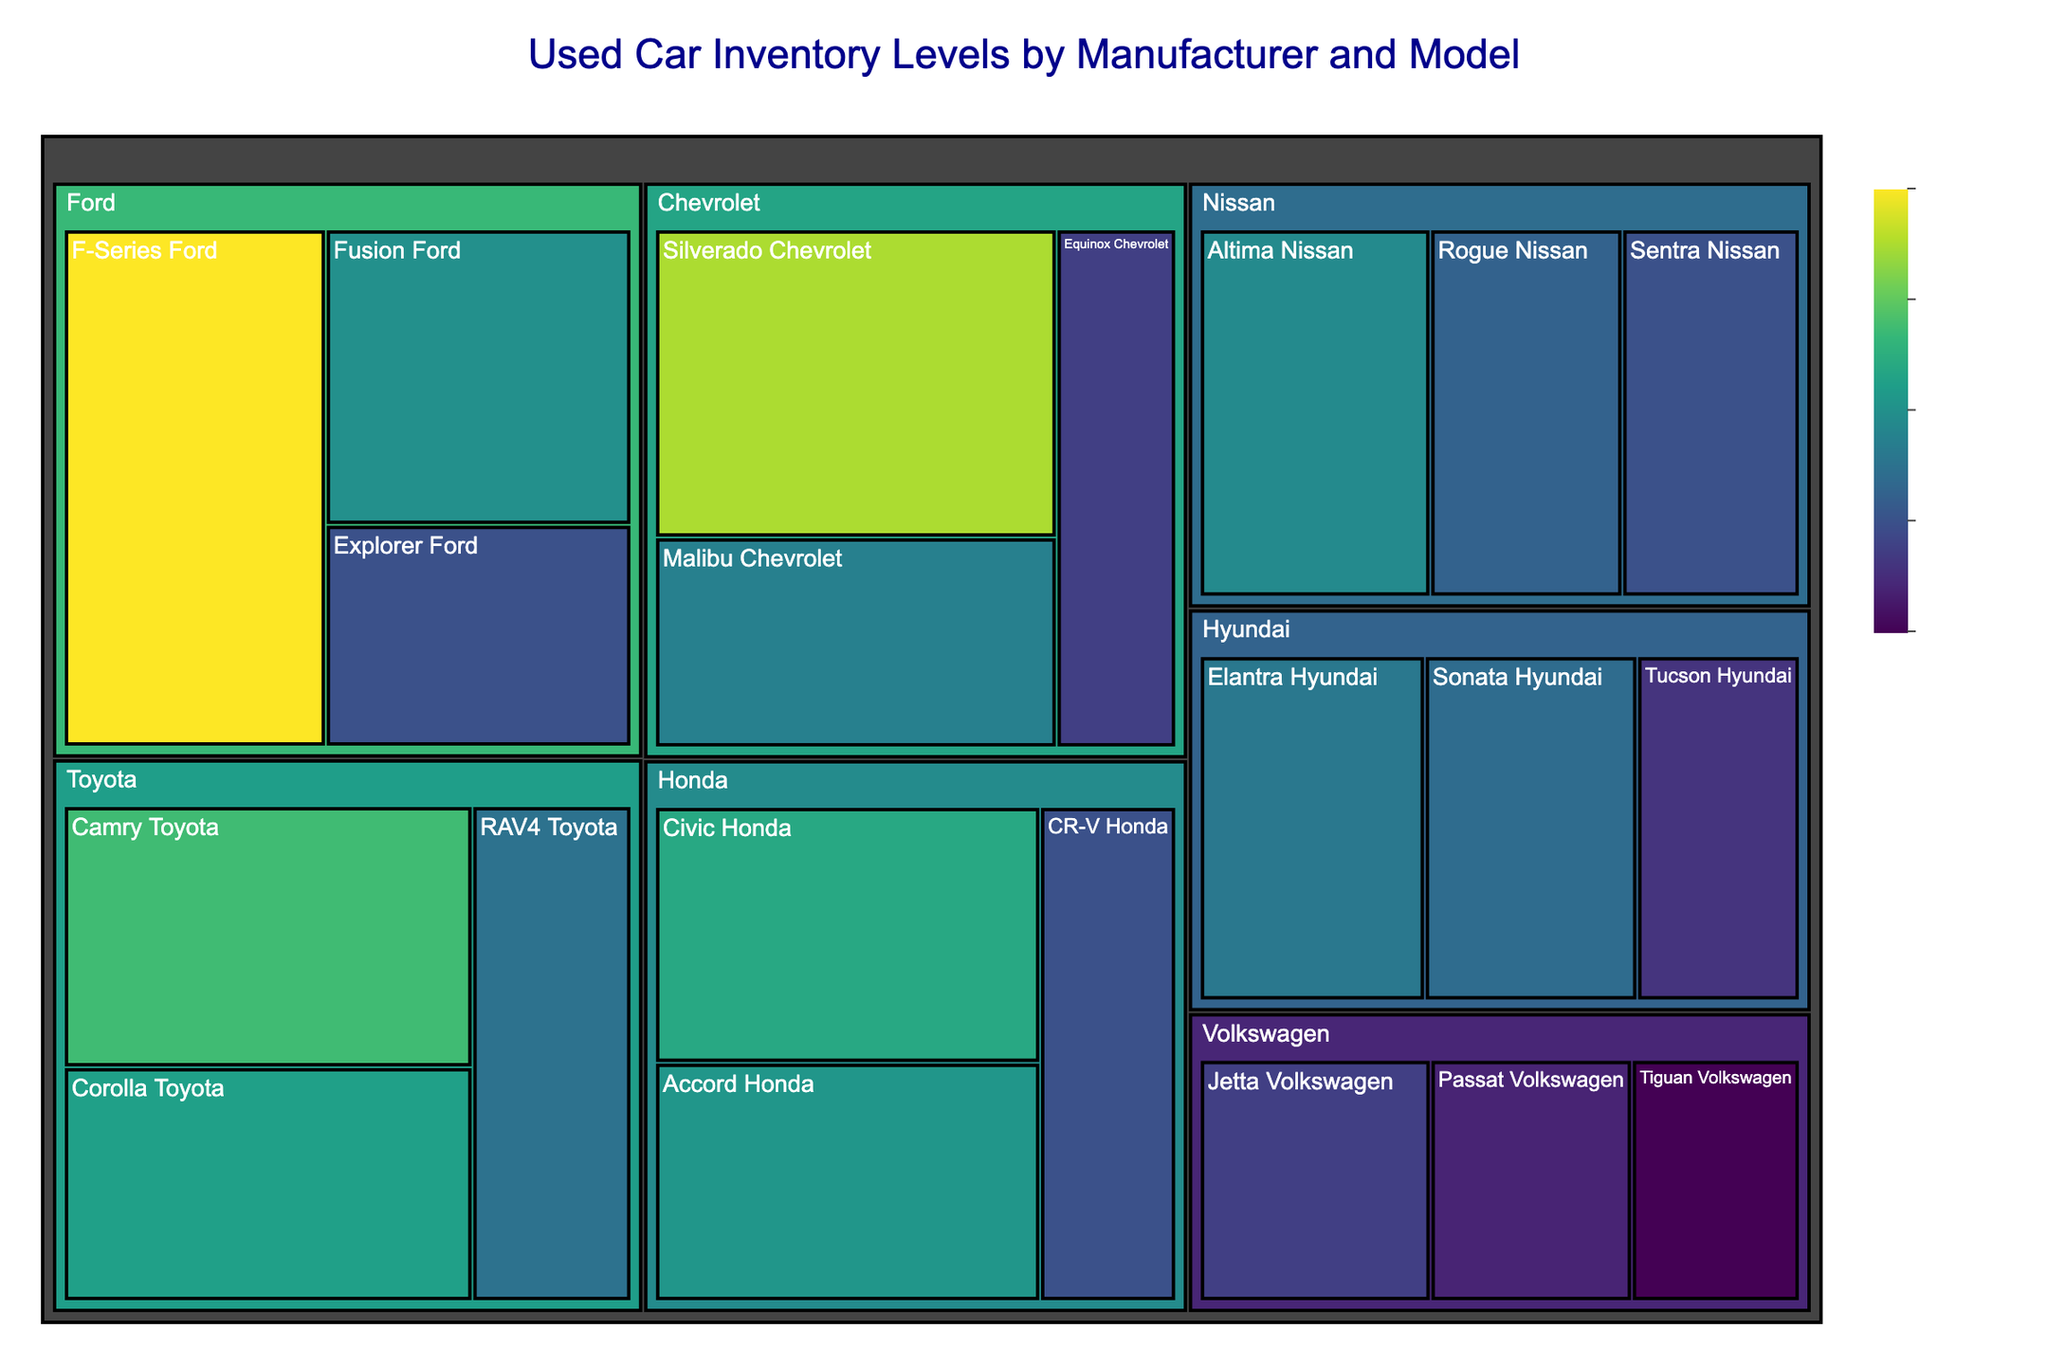what is the color theme of the treemap? The color theme of the treemap is referred to as ‘Viridis’. This is displayed by the different shades of color showing the quantity of used cars in inventory.
Answer: Viridis How many Ford vehicles are shown in total? According to the treemap, the Ford section includes the F-Series, Fusion, and Explorer models. Summing their inventories gives 1200 + 800 + 600 = 2600 cars.
Answer: 2600 What's the title of the treemap? The title of the treemap is prominently displayed at the top center of the figure.
Answer: Used Car Inventory Levels by Manufacturer and Model Which manufacturer has the smallest inventory for a single model? By examining the rectangle sizes and hovering data, Volkswagen holds the smallest inventory for a single model with the Tiguan model.
Answer: Volkswagen Tiguan What is the inventory difference between Honda and Hyundai? Summing the inventories for Honda (Civic 880, Accord 820, CR-V 600) = 2300 cars and Hyundai (Elantra 720, Sonata 680, Tucson 520) = 1920 cars and then calculating the difference = 2300 - 1920 = 380 cars.
Answer: 380 Which Ford model has the highest inventory level? By observing the Ford section of the treemap, the model with the largest area corresponds to the highest inventory, which is the F-Series.
Answer: F-Series Which model has a similar inventory level to Toyota's RAV4? By comparing the sizes and hover data of rectangles, Ford's Explorer, Honda's CR-V, and Nissan's Sentra have similar inventory levels to Toyota's RAV4 with 600 cars.
Answer: Ford Explorer, Honda CR-V, Nissan Sentra What is the most common color in the Volkswagen section? The color in the Volkswagen section gradient closest to the higher end (more inventory) is various hues of green and yellow.
Answer: Green and Yellow Which model represents the largest area in the treemap? By evaluating the area sizes of all rectangles, the Ford F-Series represents the largest area, indicating it has the highest inventory among all models.
Answer: Ford F-Series How does the Nissan Altima compare to the Hyundai Elantra in terms of inventory? From the hover data and relative area size, the inventory for the Nissan Altima is 780 cars, while the Hyundai Elantra has 720 cars, hence the Altima has a larger inventory.
Answer: Nissan Altima 